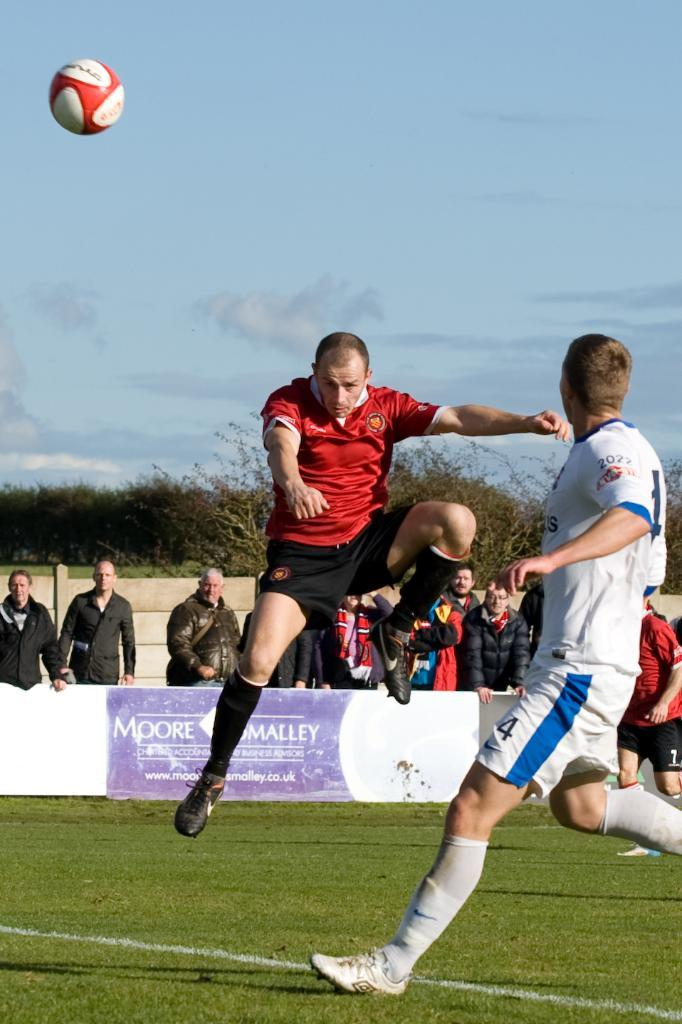<image>
Provide a brief description of the given image. A soccer player leaps in the air in front of a banner that reads, "Moore Smalley." 